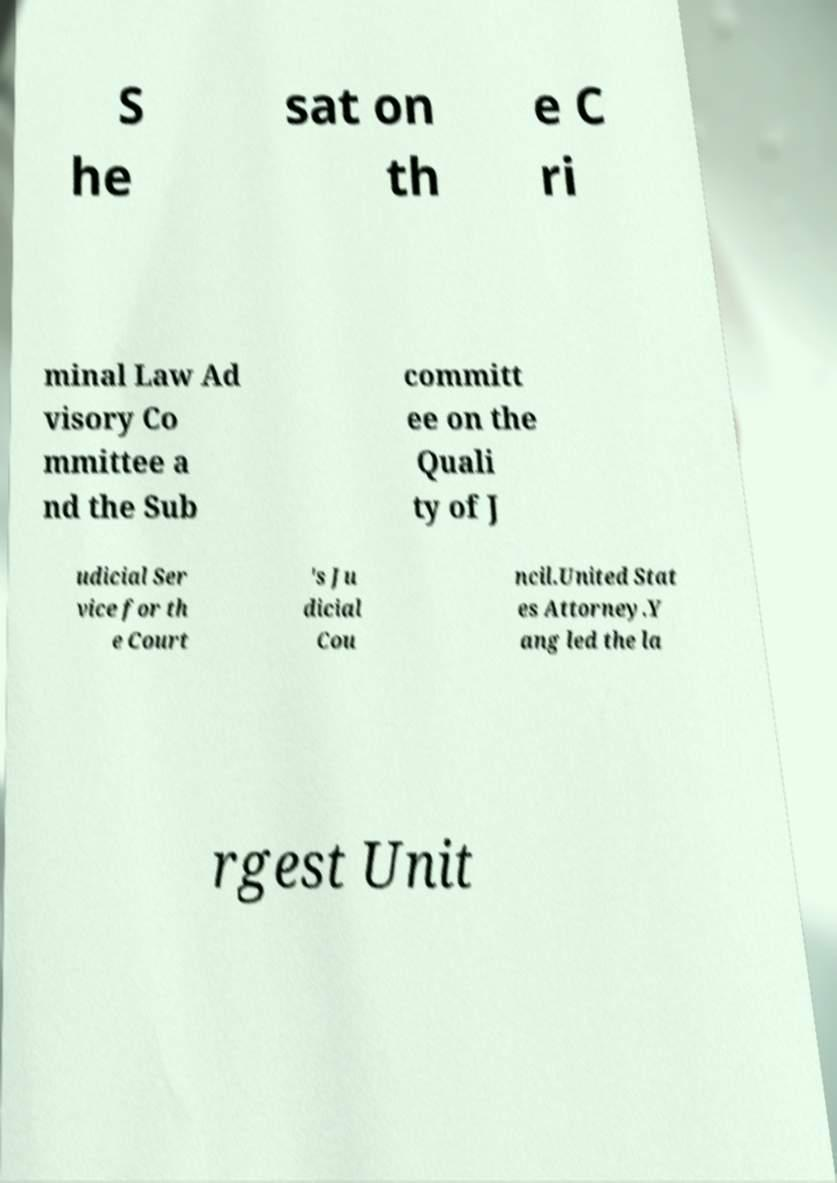Can you read and provide the text displayed in the image?This photo seems to have some interesting text. Can you extract and type it out for me? S he sat on th e C ri minal Law Ad visory Co mmittee a nd the Sub committ ee on the Quali ty of J udicial Ser vice for th e Court 's Ju dicial Cou ncil.United Stat es Attorney.Y ang led the la rgest Unit 